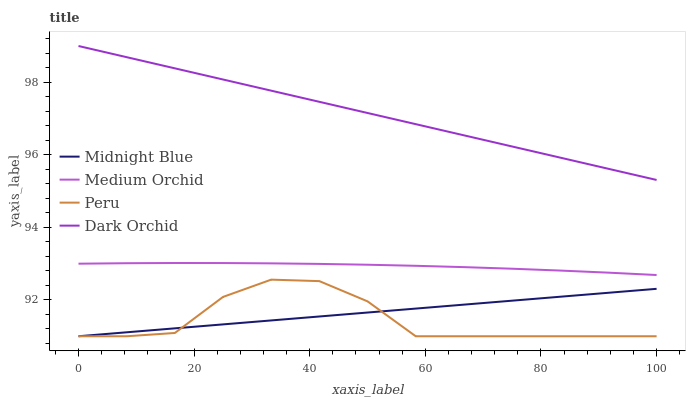Does Peru have the minimum area under the curve?
Answer yes or no. Yes. Does Dark Orchid have the maximum area under the curve?
Answer yes or no. Yes. Does Medium Orchid have the minimum area under the curve?
Answer yes or no. No. Does Medium Orchid have the maximum area under the curve?
Answer yes or no. No. Is Midnight Blue the smoothest?
Answer yes or no. Yes. Is Peru the roughest?
Answer yes or no. Yes. Is Medium Orchid the smoothest?
Answer yes or no. No. Is Medium Orchid the roughest?
Answer yes or no. No. Does Medium Orchid have the lowest value?
Answer yes or no. No. Does Dark Orchid have the highest value?
Answer yes or no. Yes. Does Medium Orchid have the highest value?
Answer yes or no. No. Is Peru less than Dark Orchid?
Answer yes or no. Yes. Is Medium Orchid greater than Midnight Blue?
Answer yes or no. Yes. Does Peru intersect Midnight Blue?
Answer yes or no. Yes. Is Peru less than Midnight Blue?
Answer yes or no. No. Is Peru greater than Midnight Blue?
Answer yes or no. No. Does Peru intersect Dark Orchid?
Answer yes or no. No. 